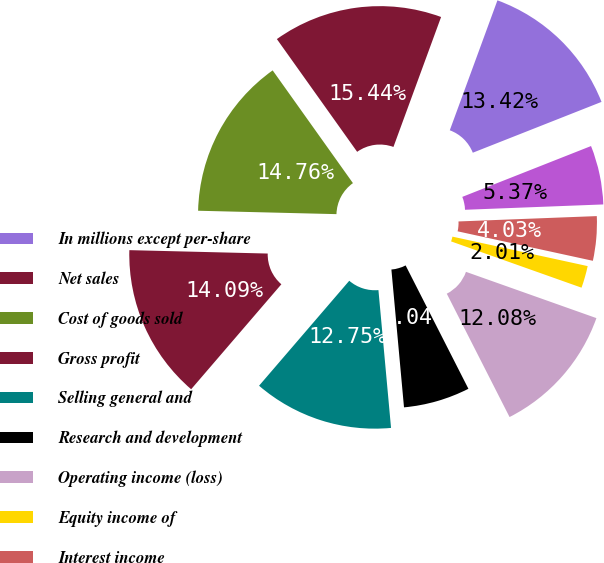Convert chart to OTSL. <chart><loc_0><loc_0><loc_500><loc_500><pie_chart><fcel>In millions except per-share<fcel>Net sales<fcel>Cost of goods sold<fcel>Gross profit<fcel>Selling general and<fcel>Research and development<fcel>Operating income (loss)<fcel>Equity income of<fcel>Interest income<fcel>Interest expense<nl><fcel>13.42%<fcel>15.44%<fcel>14.76%<fcel>14.09%<fcel>12.75%<fcel>6.04%<fcel>12.08%<fcel>2.01%<fcel>4.03%<fcel>5.37%<nl></chart> 